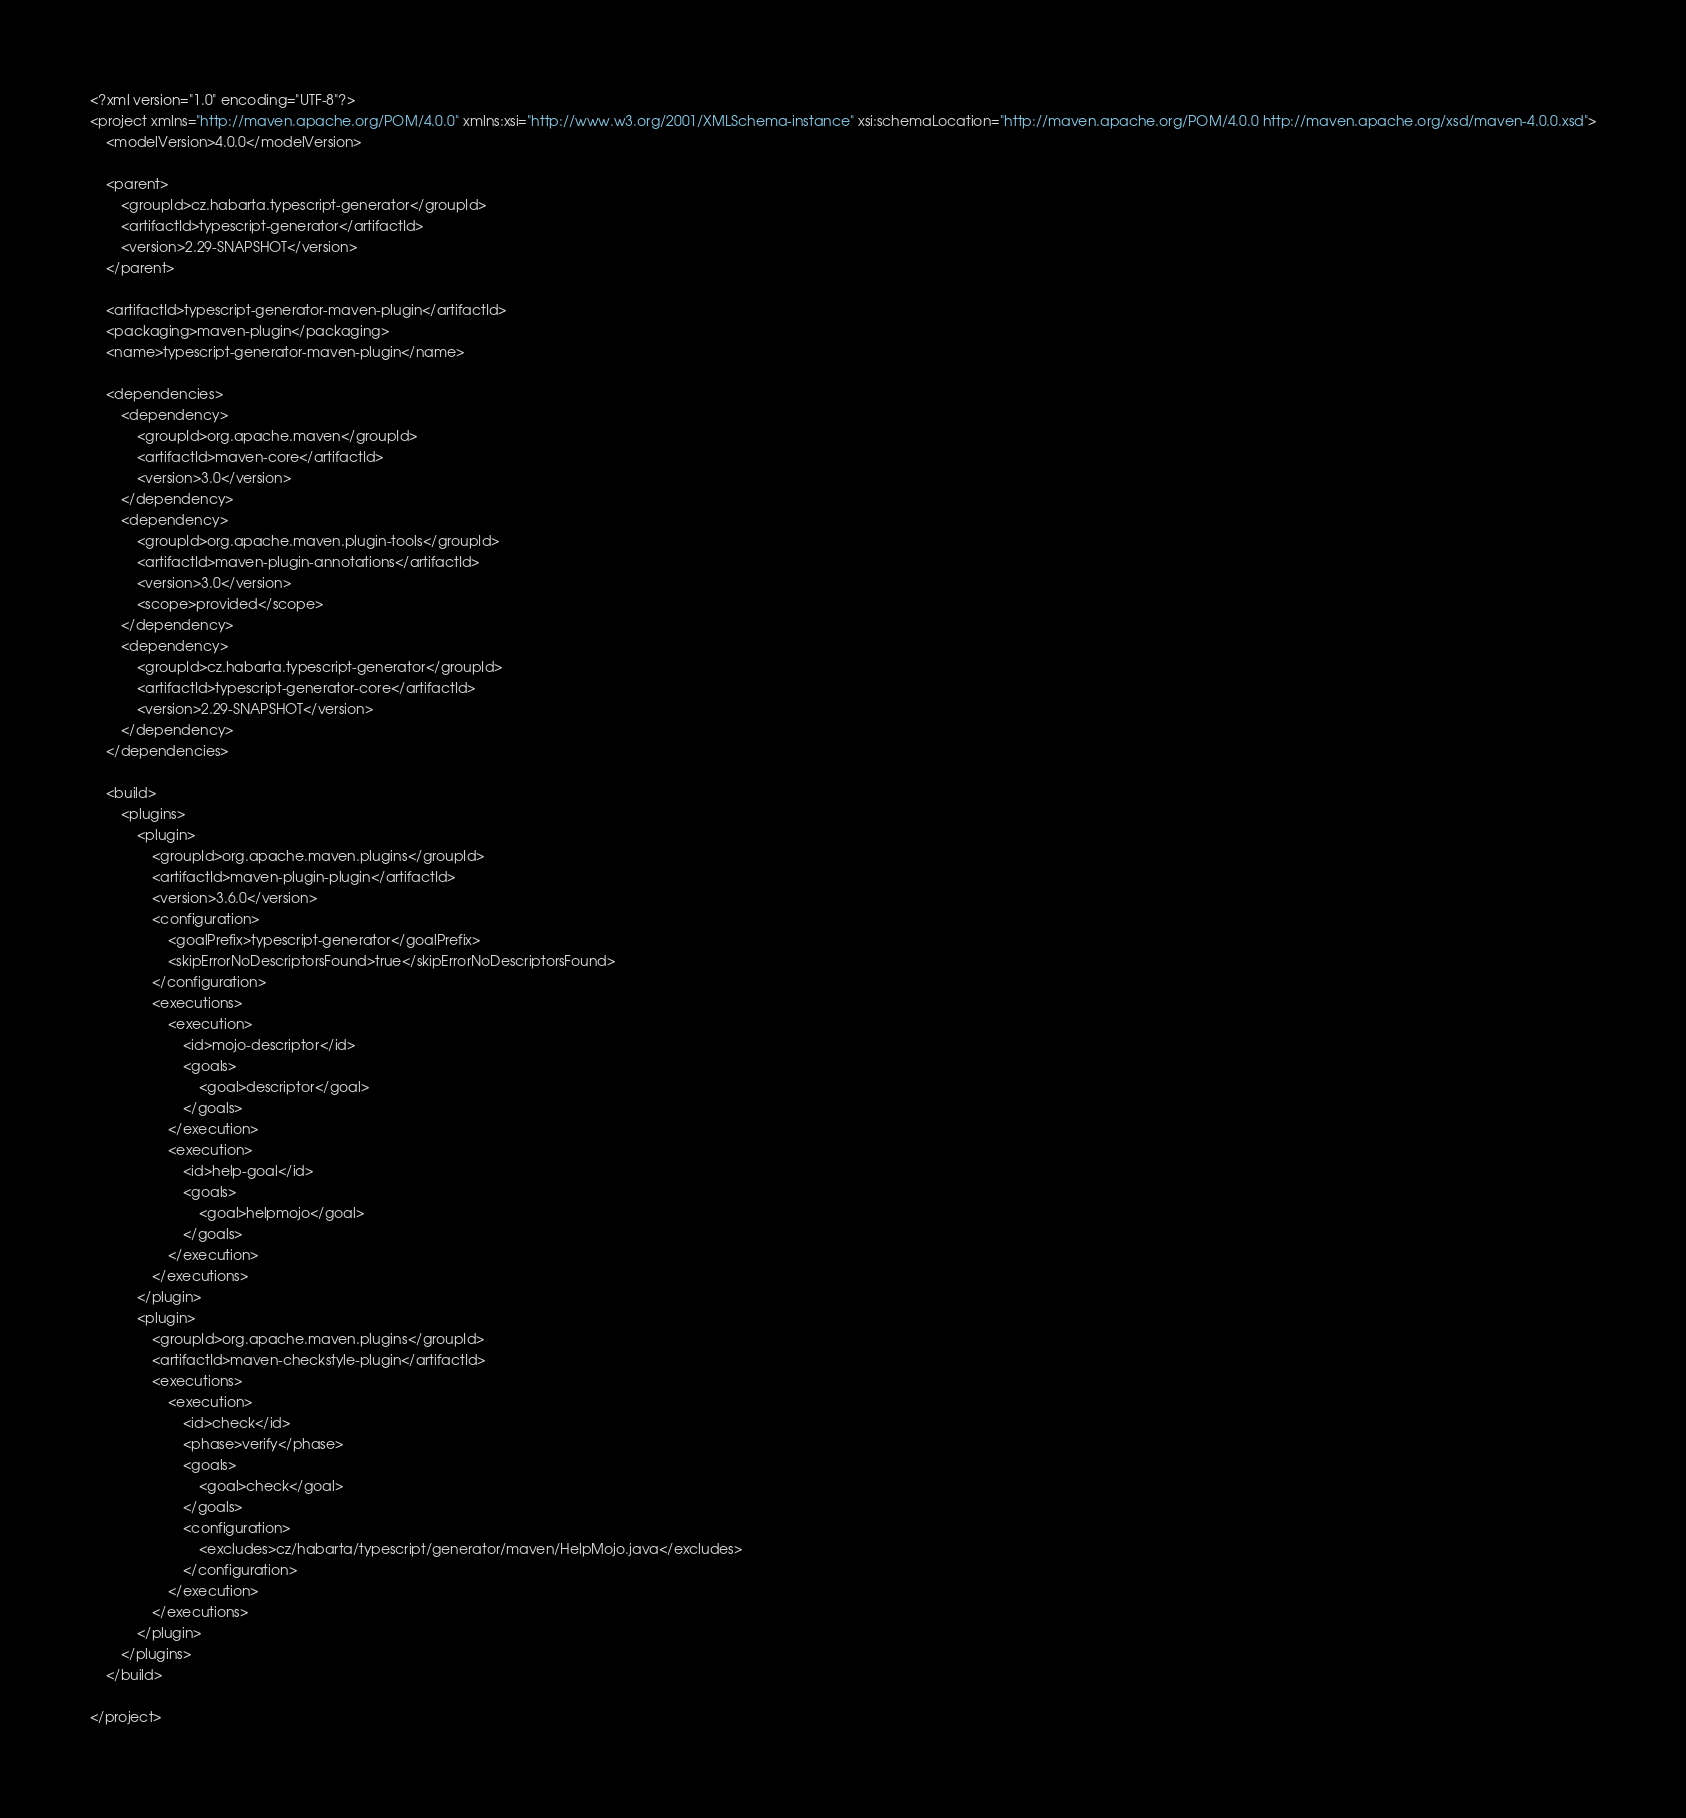Convert code to text. <code><loc_0><loc_0><loc_500><loc_500><_XML_><?xml version="1.0" encoding="UTF-8"?>
<project xmlns="http://maven.apache.org/POM/4.0.0" xmlns:xsi="http://www.w3.org/2001/XMLSchema-instance" xsi:schemaLocation="http://maven.apache.org/POM/4.0.0 http://maven.apache.org/xsd/maven-4.0.0.xsd">
    <modelVersion>4.0.0</modelVersion>

    <parent>
        <groupId>cz.habarta.typescript-generator</groupId>
        <artifactId>typescript-generator</artifactId>
        <version>2.29-SNAPSHOT</version>
    </parent>

    <artifactId>typescript-generator-maven-plugin</artifactId>
    <packaging>maven-plugin</packaging>
    <name>typescript-generator-maven-plugin</name>

    <dependencies>
        <dependency>
            <groupId>org.apache.maven</groupId>
            <artifactId>maven-core</artifactId>
            <version>3.0</version>
        </dependency>
        <dependency>
            <groupId>org.apache.maven.plugin-tools</groupId>
            <artifactId>maven-plugin-annotations</artifactId>
            <version>3.0</version>
            <scope>provided</scope>
        </dependency>
        <dependency>
            <groupId>cz.habarta.typescript-generator</groupId>
            <artifactId>typescript-generator-core</artifactId>
            <version>2.29-SNAPSHOT</version>
        </dependency>
    </dependencies>

    <build>
        <plugins>
            <plugin>
                <groupId>org.apache.maven.plugins</groupId>
                <artifactId>maven-plugin-plugin</artifactId>
                <version>3.6.0</version>
                <configuration>
                    <goalPrefix>typescript-generator</goalPrefix>
                    <skipErrorNoDescriptorsFound>true</skipErrorNoDescriptorsFound>
                </configuration>
                <executions>
                    <execution>
                        <id>mojo-descriptor</id>
                        <goals>
                            <goal>descriptor</goal>
                        </goals>
                    </execution>
                    <execution>
                        <id>help-goal</id>
                        <goals>
                            <goal>helpmojo</goal>
                        </goals>
                    </execution>
                </executions>
            </plugin>
            <plugin>
                <groupId>org.apache.maven.plugins</groupId>
                <artifactId>maven-checkstyle-plugin</artifactId>
                <executions>
                    <execution>
                        <id>check</id>
                        <phase>verify</phase>
                        <goals>
                            <goal>check</goal>
                        </goals>
                        <configuration>
                            <excludes>cz/habarta/typescript/generator/maven/HelpMojo.java</excludes>
                        </configuration>
                    </execution>
                </executions>
            </plugin>
        </plugins>
    </build>

</project>
</code> 